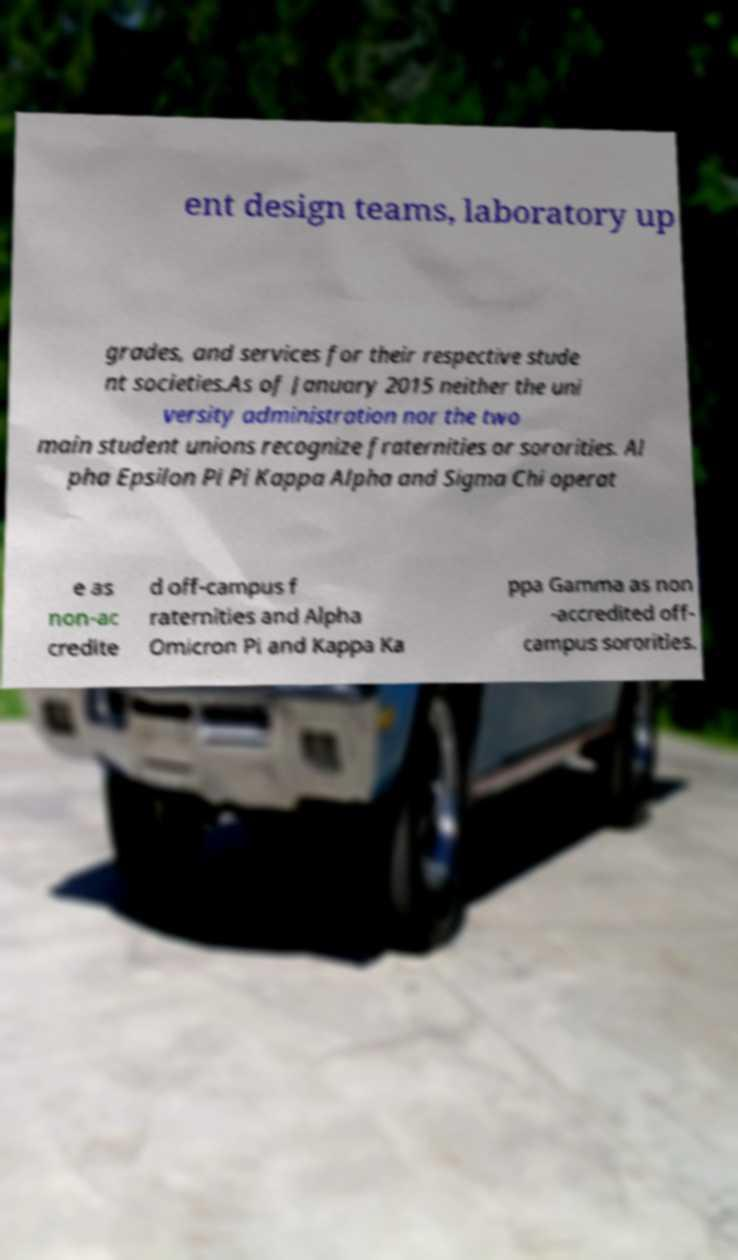Please identify and transcribe the text found in this image. ent design teams, laboratory up grades, and services for their respective stude nt societies.As of January 2015 neither the uni versity administration nor the two main student unions recognize fraternities or sororities. Al pha Epsilon Pi Pi Kappa Alpha and Sigma Chi operat e as non-ac credite d off-campus f raternities and Alpha Omicron Pi and Kappa Ka ppa Gamma as non -accredited off- campus sororities. 